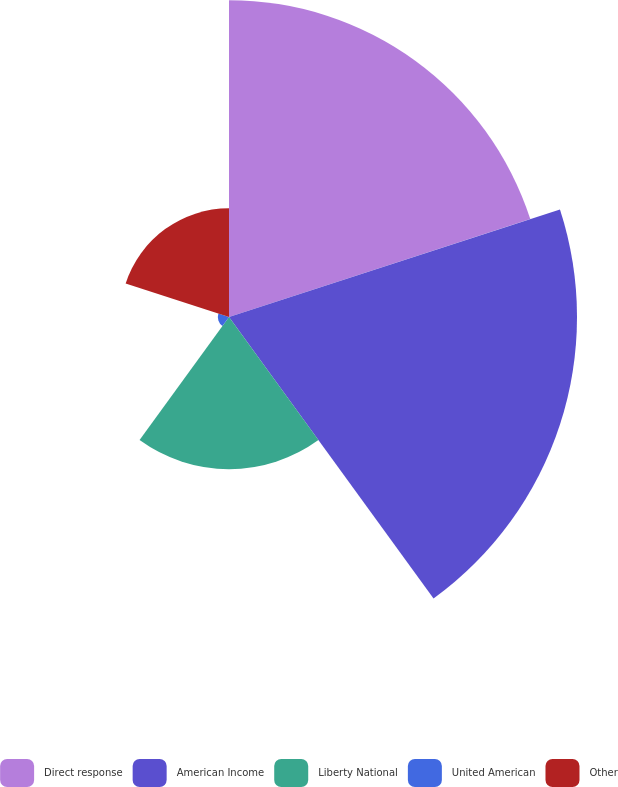Convert chart. <chart><loc_0><loc_0><loc_500><loc_500><pie_chart><fcel>Direct response<fcel>American Income<fcel>Liberty National<fcel>United American<fcel>Other<nl><fcel>33.82%<fcel>37.15%<fcel>16.24%<fcel>1.19%<fcel>11.6%<nl></chart> 